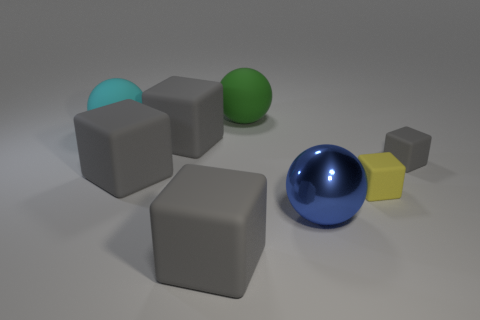There is a block in front of the yellow block; is it the same color as the matte cube that is right of the yellow rubber cube?
Your answer should be very brief. Yes. How many things are either spheres that are in front of the yellow rubber block or gray objects that are in front of the large blue metal thing?
Ensure brevity in your answer.  2. What number of other things are the same size as the yellow block?
Offer a very short reply. 1. There is a object that is behind the tiny gray object and in front of the cyan matte thing; what is its size?
Ensure brevity in your answer.  Large. What number of small objects are blue balls or rubber things?
Keep it short and to the point. 2. What shape is the big object on the right side of the large green matte sphere?
Give a very brief answer. Sphere. How many small red metallic things are there?
Make the answer very short. 0. Is the material of the yellow block the same as the large green ball?
Provide a short and direct response. Yes. Are there more green matte spheres that are left of the blue metallic sphere than large purple metallic cubes?
Your response must be concise. Yes. How many things are green balls or big matte objects that are in front of the shiny sphere?
Your response must be concise. 2. 